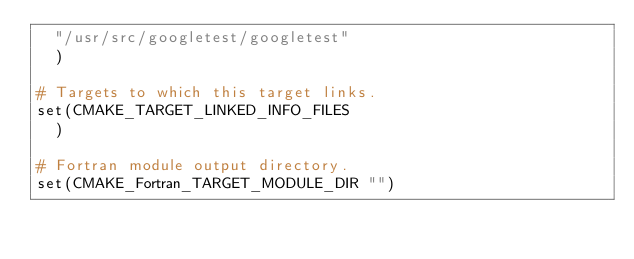Convert code to text. <code><loc_0><loc_0><loc_500><loc_500><_CMake_>  "/usr/src/googletest/googletest"
  )

# Targets to which this target links.
set(CMAKE_TARGET_LINKED_INFO_FILES
  )

# Fortran module output directory.
set(CMAKE_Fortran_TARGET_MODULE_DIR "")
</code> 